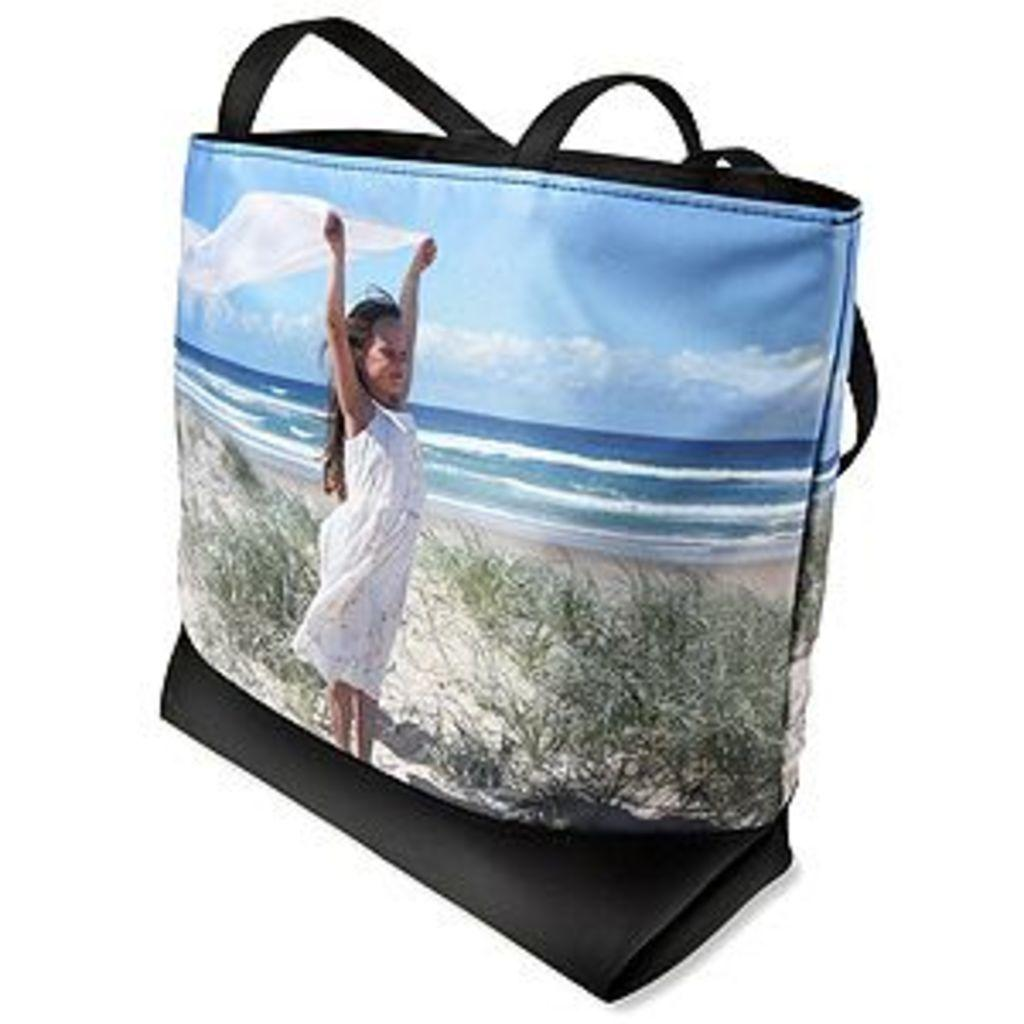What is depicted on the bag in the image? There is a photo of a kid on the bag. What is the kid doing in the photo? The kid is holding a scarf in her hands in the photo. What can be seen in the background of the photo? The sky, clouds, water, and plants are present in the photo. How many slaves are visible in the photo on the bag? There are no slaves present in the photo; it features a kid holding a scarf. What type of attention is the kid seeking in the photo? The photo does not indicate that the kid is seeking any specific type of attention. 